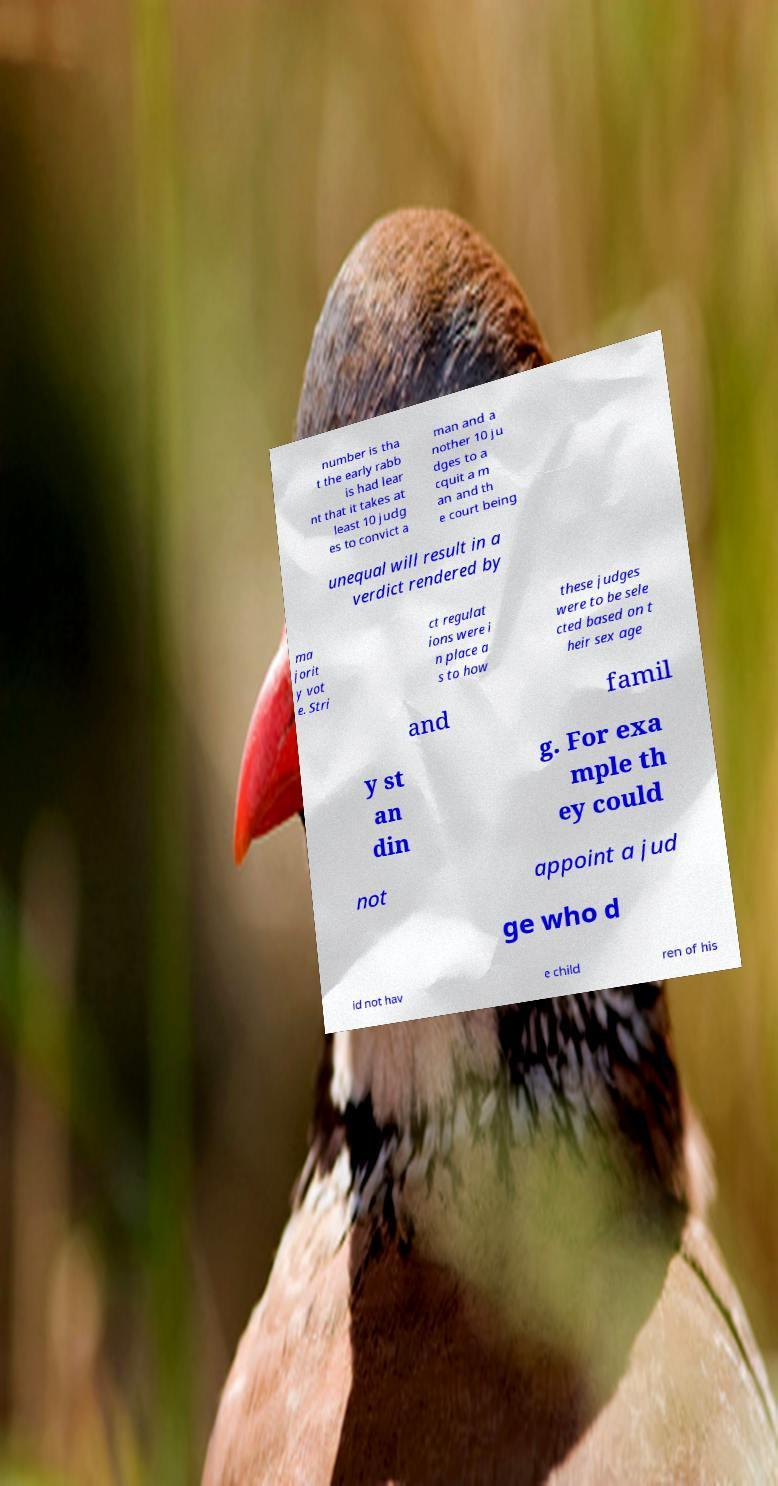Please read and relay the text visible in this image. What does it say? number is tha t the early rabb is had lear nt that it takes at least 10 judg es to convict a man and a nother 10 ju dges to a cquit a m an and th e court being unequal will result in a verdict rendered by ma jorit y vot e. Stri ct regulat ions were i n place a s to how these judges were to be sele cted based on t heir sex age and famil y st an din g. For exa mple th ey could not appoint a jud ge who d id not hav e child ren of his 